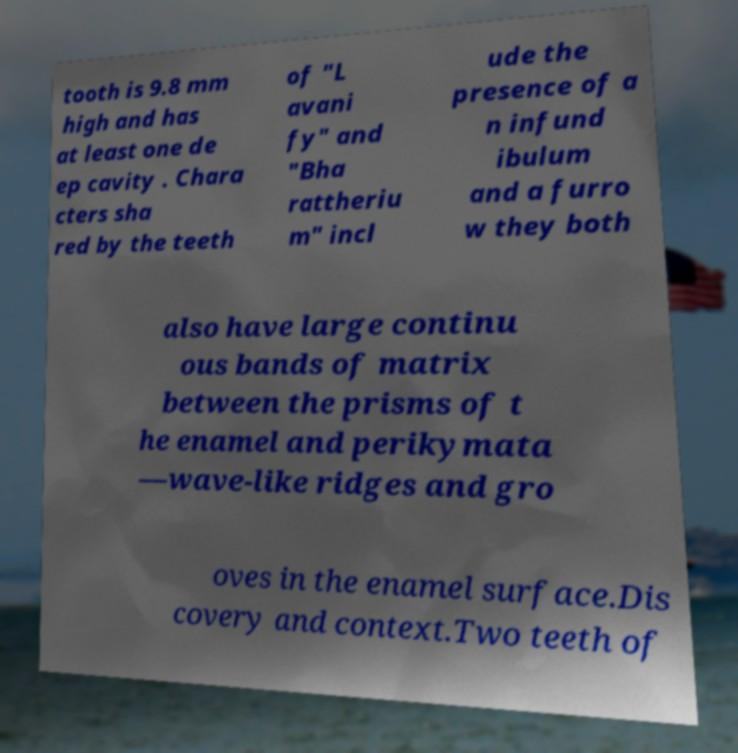Please read and relay the text visible in this image. What does it say? tooth is 9.8 mm high and has at least one de ep cavity . Chara cters sha red by the teeth of "L avani fy" and "Bha rattheriu m" incl ude the presence of a n infund ibulum and a furro w they both also have large continu ous bands of matrix between the prisms of t he enamel and perikymata —wave-like ridges and gro oves in the enamel surface.Dis covery and context.Two teeth of 